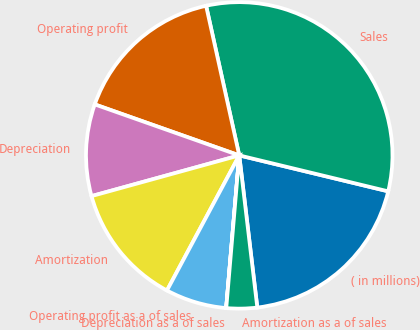<chart> <loc_0><loc_0><loc_500><loc_500><pie_chart><fcel>( in millions)<fcel>Sales<fcel>Operating profit<fcel>Depreciation<fcel>Amortization<fcel>Operating profit as a of sales<fcel>Depreciation as a of sales<fcel>Amortization as a of sales<nl><fcel>19.35%<fcel>32.24%<fcel>16.13%<fcel>9.68%<fcel>12.9%<fcel>6.46%<fcel>0.01%<fcel>3.23%<nl></chart> 